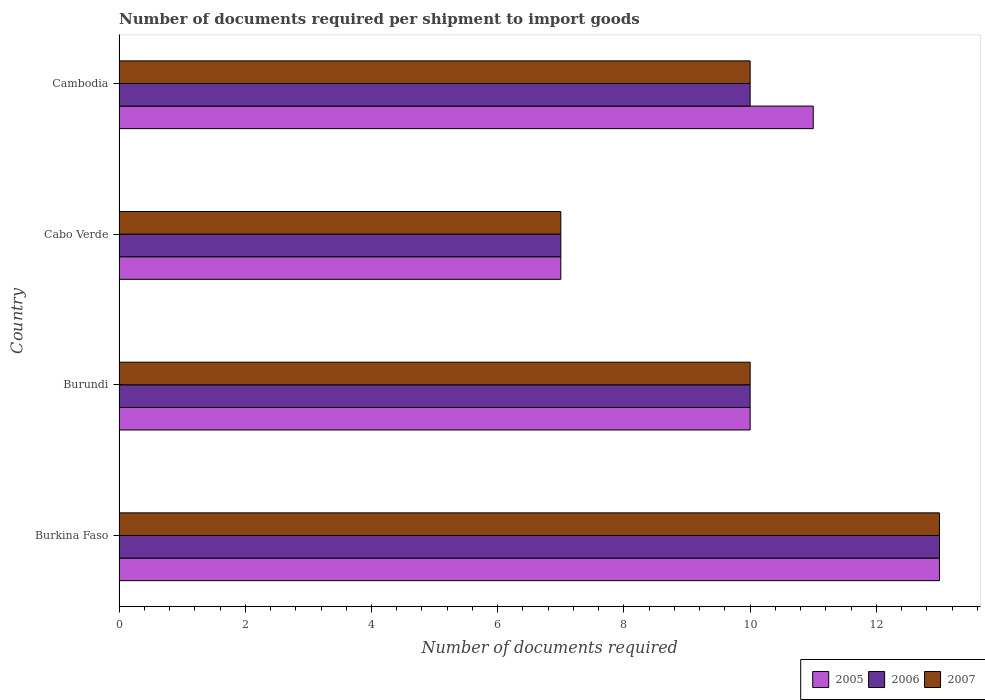How many different coloured bars are there?
Provide a succinct answer. 3. How many groups of bars are there?
Make the answer very short. 4. Are the number of bars on each tick of the Y-axis equal?
Keep it short and to the point. Yes. How many bars are there on the 3rd tick from the top?
Make the answer very short. 3. What is the label of the 1st group of bars from the top?
Keep it short and to the point. Cambodia. In how many cases, is the number of bars for a given country not equal to the number of legend labels?
Keep it short and to the point. 0. Across all countries, what is the maximum number of documents required per shipment to import goods in 2006?
Make the answer very short. 13. Across all countries, what is the minimum number of documents required per shipment to import goods in 2005?
Keep it short and to the point. 7. In which country was the number of documents required per shipment to import goods in 2007 maximum?
Provide a short and direct response. Burkina Faso. In which country was the number of documents required per shipment to import goods in 2007 minimum?
Your response must be concise. Cabo Verde. What is the difference between the number of documents required per shipment to import goods in 2005 in Burundi and that in Cabo Verde?
Offer a terse response. 3. What is the average number of documents required per shipment to import goods in 2006 per country?
Offer a very short reply. 10. What is the difference between the number of documents required per shipment to import goods in 2006 and number of documents required per shipment to import goods in 2007 in Cambodia?
Ensure brevity in your answer.  0. In how many countries, is the number of documents required per shipment to import goods in 2005 greater than 11.2 ?
Your response must be concise. 1. What is the ratio of the number of documents required per shipment to import goods in 2006 in Burkina Faso to that in Cabo Verde?
Give a very brief answer. 1.86. Is the difference between the number of documents required per shipment to import goods in 2006 in Burkina Faso and Burundi greater than the difference between the number of documents required per shipment to import goods in 2007 in Burkina Faso and Burundi?
Provide a succinct answer. No. Is the sum of the number of documents required per shipment to import goods in 2006 in Burkina Faso and Cabo Verde greater than the maximum number of documents required per shipment to import goods in 2007 across all countries?
Ensure brevity in your answer.  Yes. Is it the case that in every country, the sum of the number of documents required per shipment to import goods in 2005 and number of documents required per shipment to import goods in 2007 is greater than the number of documents required per shipment to import goods in 2006?
Provide a short and direct response. Yes. Are all the bars in the graph horizontal?
Provide a short and direct response. Yes. Are the values on the major ticks of X-axis written in scientific E-notation?
Keep it short and to the point. No. Does the graph contain grids?
Keep it short and to the point. No. How are the legend labels stacked?
Make the answer very short. Horizontal. What is the title of the graph?
Keep it short and to the point. Number of documents required per shipment to import goods. Does "2011" appear as one of the legend labels in the graph?
Keep it short and to the point. No. What is the label or title of the X-axis?
Offer a terse response. Number of documents required. What is the label or title of the Y-axis?
Keep it short and to the point. Country. What is the Number of documents required of 2005 in Burkina Faso?
Your response must be concise. 13. What is the Number of documents required in 2006 in Burundi?
Your answer should be very brief. 10. What is the Number of documents required of 2007 in Burundi?
Keep it short and to the point. 10. What is the Number of documents required of 2005 in Cabo Verde?
Your response must be concise. 7. What is the Number of documents required of 2006 in Cabo Verde?
Give a very brief answer. 7. What is the Number of documents required in 2005 in Cambodia?
Provide a short and direct response. 11. What is the Number of documents required in 2006 in Cambodia?
Provide a succinct answer. 10. What is the Number of documents required in 2007 in Cambodia?
Your answer should be very brief. 10. Across all countries, what is the maximum Number of documents required in 2005?
Your answer should be compact. 13. Across all countries, what is the maximum Number of documents required in 2007?
Offer a terse response. 13. Across all countries, what is the minimum Number of documents required of 2005?
Your answer should be compact. 7. What is the total Number of documents required in 2005 in the graph?
Offer a very short reply. 41. What is the total Number of documents required of 2006 in the graph?
Offer a terse response. 40. What is the difference between the Number of documents required of 2005 in Burkina Faso and that in Burundi?
Provide a short and direct response. 3. What is the difference between the Number of documents required of 2006 in Burkina Faso and that in Burundi?
Give a very brief answer. 3. What is the difference between the Number of documents required in 2006 in Burkina Faso and that in Cabo Verde?
Your answer should be compact. 6. What is the difference between the Number of documents required in 2006 in Burkina Faso and that in Cambodia?
Give a very brief answer. 3. What is the difference between the Number of documents required of 2005 in Burundi and that in Cabo Verde?
Make the answer very short. 3. What is the difference between the Number of documents required of 2007 in Burundi and that in Cambodia?
Make the answer very short. 0. What is the difference between the Number of documents required of 2007 in Cabo Verde and that in Cambodia?
Keep it short and to the point. -3. What is the difference between the Number of documents required in 2005 in Burkina Faso and the Number of documents required in 2006 in Burundi?
Offer a terse response. 3. What is the difference between the Number of documents required in 2005 in Burkina Faso and the Number of documents required in 2007 in Burundi?
Offer a terse response. 3. What is the difference between the Number of documents required of 2006 in Burkina Faso and the Number of documents required of 2007 in Burundi?
Give a very brief answer. 3. What is the difference between the Number of documents required in 2005 in Burkina Faso and the Number of documents required in 2007 in Cabo Verde?
Your answer should be compact. 6. What is the difference between the Number of documents required of 2005 in Burkina Faso and the Number of documents required of 2006 in Cambodia?
Provide a short and direct response. 3. What is the difference between the Number of documents required of 2006 in Burkina Faso and the Number of documents required of 2007 in Cambodia?
Make the answer very short. 3. What is the difference between the Number of documents required in 2005 in Burundi and the Number of documents required in 2007 in Cabo Verde?
Make the answer very short. 3. What is the difference between the Number of documents required in 2006 in Burundi and the Number of documents required in 2007 in Cambodia?
Your answer should be compact. 0. What is the difference between the Number of documents required in 2005 in Cabo Verde and the Number of documents required in 2006 in Cambodia?
Make the answer very short. -3. What is the average Number of documents required of 2005 per country?
Give a very brief answer. 10.25. What is the average Number of documents required of 2007 per country?
Provide a succinct answer. 10. What is the difference between the Number of documents required of 2005 and Number of documents required of 2007 in Burkina Faso?
Keep it short and to the point. 0. What is the difference between the Number of documents required of 2006 and Number of documents required of 2007 in Burkina Faso?
Provide a succinct answer. 0. What is the difference between the Number of documents required of 2005 and Number of documents required of 2006 in Burundi?
Provide a succinct answer. 0. What is the difference between the Number of documents required of 2006 and Number of documents required of 2007 in Burundi?
Offer a very short reply. 0. What is the difference between the Number of documents required of 2005 and Number of documents required of 2006 in Cabo Verde?
Offer a terse response. 0. What is the difference between the Number of documents required of 2005 and Number of documents required of 2006 in Cambodia?
Offer a very short reply. 1. What is the difference between the Number of documents required in 2005 and Number of documents required in 2007 in Cambodia?
Your answer should be compact. 1. What is the difference between the Number of documents required of 2006 and Number of documents required of 2007 in Cambodia?
Your answer should be very brief. 0. What is the ratio of the Number of documents required of 2007 in Burkina Faso to that in Burundi?
Make the answer very short. 1.3. What is the ratio of the Number of documents required of 2005 in Burkina Faso to that in Cabo Verde?
Offer a very short reply. 1.86. What is the ratio of the Number of documents required in 2006 in Burkina Faso to that in Cabo Verde?
Make the answer very short. 1.86. What is the ratio of the Number of documents required of 2007 in Burkina Faso to that in Cabo Verde?
Provide a short and direct response. 1.86. What is the ratio of the Number of documents required in 2005 in Burkina Faso to that in Cambodia?
Make the answer very short. 1.18. What is the ratio of the Number of documents required of 2006 in Burkina Faso to that in Cambodia?
Provide a short and direct response. 1.3. What is the ratio of the Number of documents required of 2007 in Burkina Faso to that in Cambodia?
Offer a terse response. 1.3. What is the ratio of the Number of documents required of 2005 in Burundi to that in Cabo Verde?
Your answer should be compact. 1.43. What is the ratio of the Number of documents required in 2006 in Burundi to that in Cabo Verde?
Your answer should be very brief. 1.43. What is the ratio of the Number of documents required of 2007 in Burundi to that in Cabo Verde?
Offer a very short reply. 1.43. What is the ratio of the Number of documents required of 2005 in Burundi to that in Cambodia?
Your answer should be compact. 0.91. What is the ratio of the Number of documents required in 2006 in Burundi to that in Cambodia?
Provide a succinct answer. 1. What is the ratio of the Number of documents required in 2007 in Burundi to that in Cambodia?
Ensure brevity in your answer.  1. What is the ratio of the Number of documents required of 2005 in Cabo Verde to that in Cambodia?
Provide a short and direct response. 0.64. What is the ratio of the Number of documents required of 2006 in Cabo Verde to that in Cambodia?
Offer a terse response. 0.7. What is the ratio of the Number of documents required in 2007 in Cabo Verde to that in Cambodia?
Make the answer very short. 0.7. What is the difference between the highest and the second highest Number of documents required in 2006?
Offer a terse response. 3. What is the difference between the highest and the second highest Number of documents required of 2007?
Give a very brief answer. 3. What is the difference between the highest and the lowest Number of documents required in 2006?
Give a very brief answer. 6. What is the difference between the highest and the lowest Number of documents required in 2007?
Give a very brief answer. 6. 